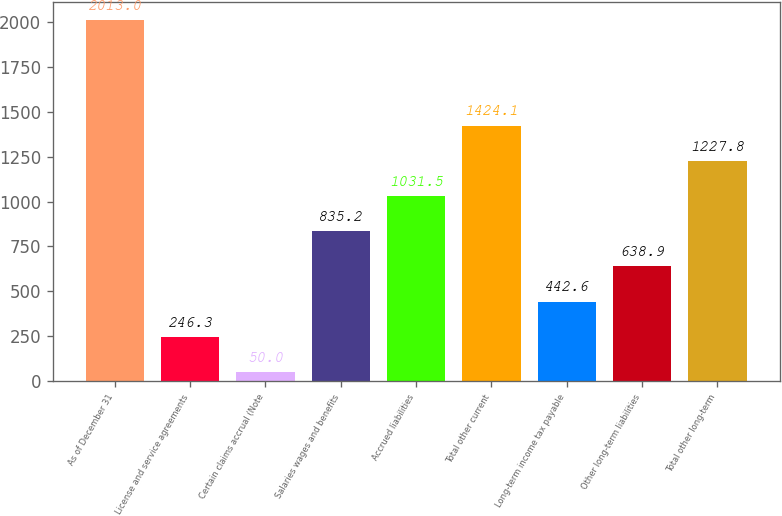<chart> <loc_0><loc_0><loc_500><loc_500><bar_chart><fcel>As of December 31<fcel>License and service agreements<fcel>Certain claims accrual (Note<fcel>Salaries wages and benefits<fcel>Accrued liabilities<fcel>Total other current<fcel>Long-term income tax payable<fcel>Other long-term liabilities<fcel>Total other long-term<nl><fcel>2013<fcel>246.3<fcel>50<fcel>835.2<fcel>1031.5<fcel>1424.1<fcel>442.6<fcel>638.9<fcel>1227.8<nl></chart> 